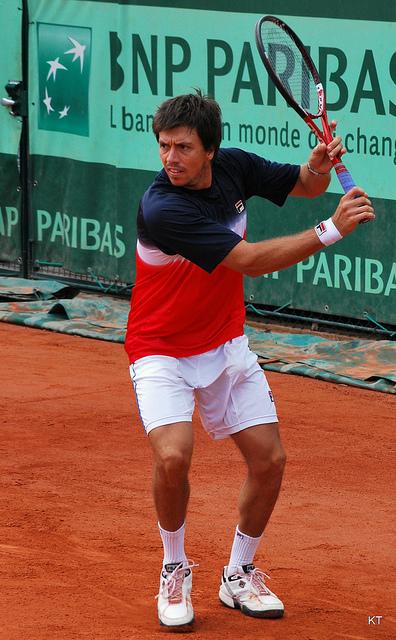Is he running?
Give a very brief answer. No. What sport is he playing?
Answer briefly. Tennis. In this photograph, what material is the playing surface made out of?
Answer briefly. Clay. Is the man jumping?
Be succinct. No. What color are his tennis shoes?
Answer briefly. White. Is the man wearing wristband?
Short answer required. Yes. 